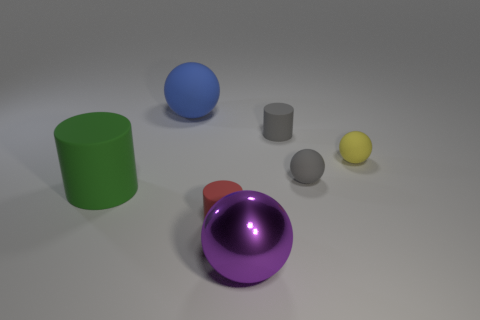What can you infer about the lighting in this scene? The lighting in this scene appears to be diffuse with soft shadows, indicating that the light source is not overly harsh or direct. This contributes to the slightly muted appearance of the objects and the softness of their shadows on the ground. 